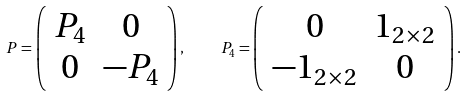<formula> <loc_0><loc_0><loc_500><loc_500>P = \left ( \begin{array} { c c } P _ { 4 } & 0 \\ 0 & - P _ { 4 } \end{array} \right ) , \quad P _ { 4 } = \left ( \begin{array} { c c } 0 & { 1 } _ { 2 \times 2 } \\ - { 1 } _ { 2 \times 2 } & 0 \end{array} \right ) .</formula> 